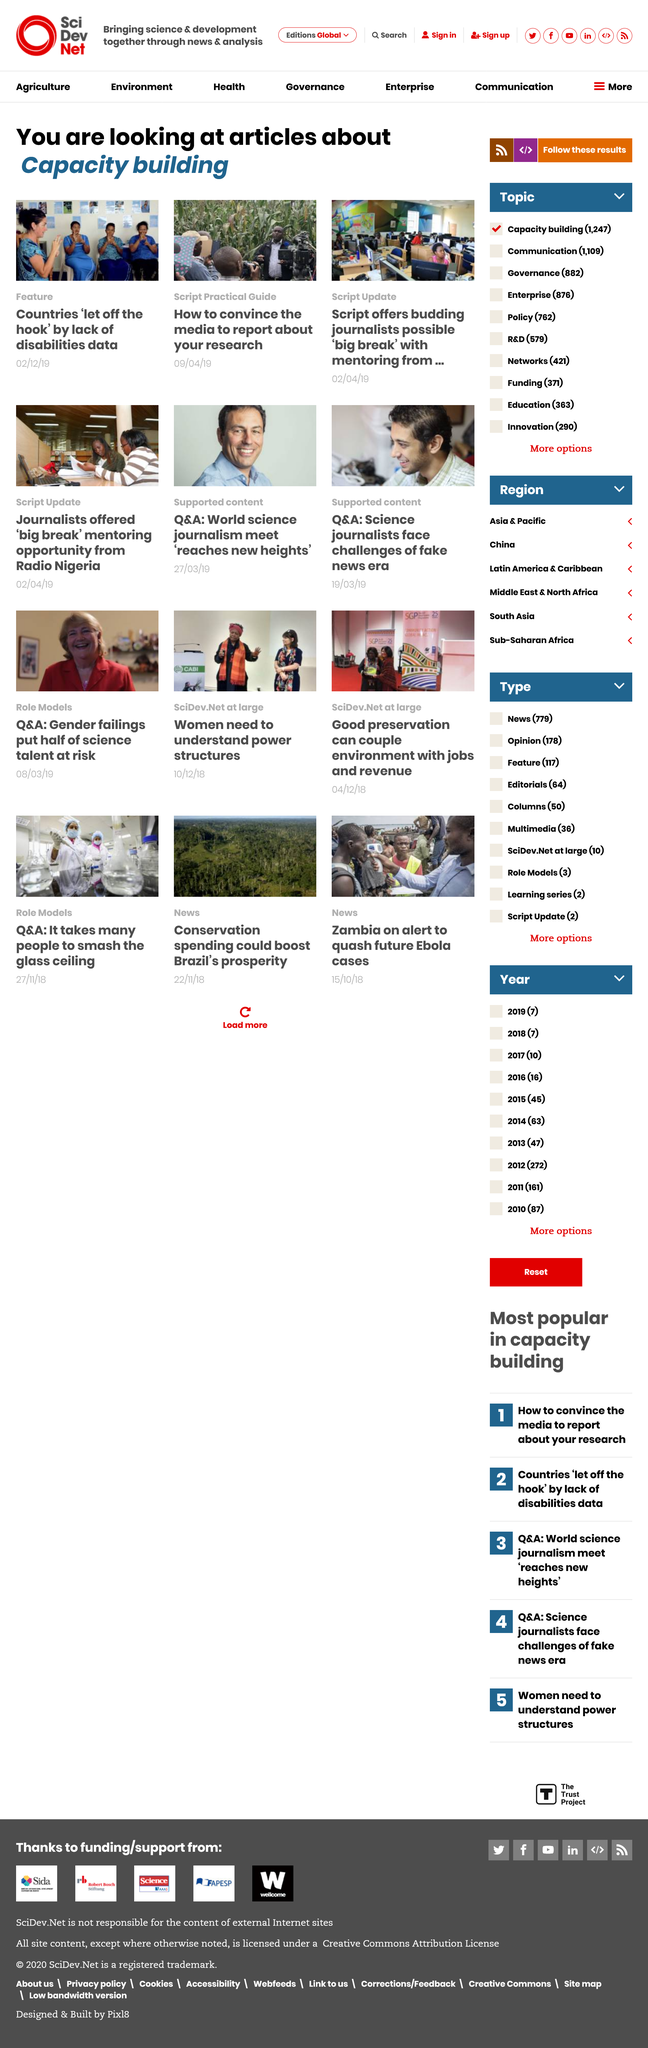Identify some key points in this picture. There are three articles within the category "capacity building". On February 12, 2019, countries were let off the hook by the lack of disability data. The Script offers budding journalists the possibility of a 'big break' through mentoring opportunities, providing them with valuable training and support to launch their careers in the media industry. 